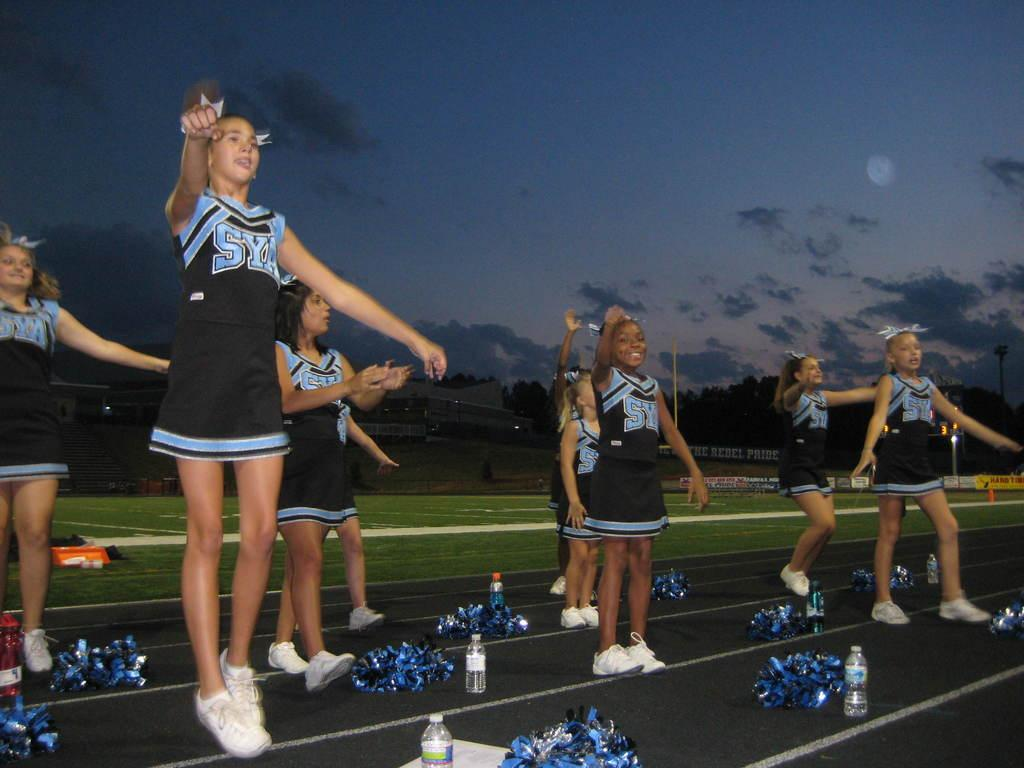<image>
Create a compact narrative representing the image presented. Cheerleaders wearing the letters SYA perform on the track by the football field. 